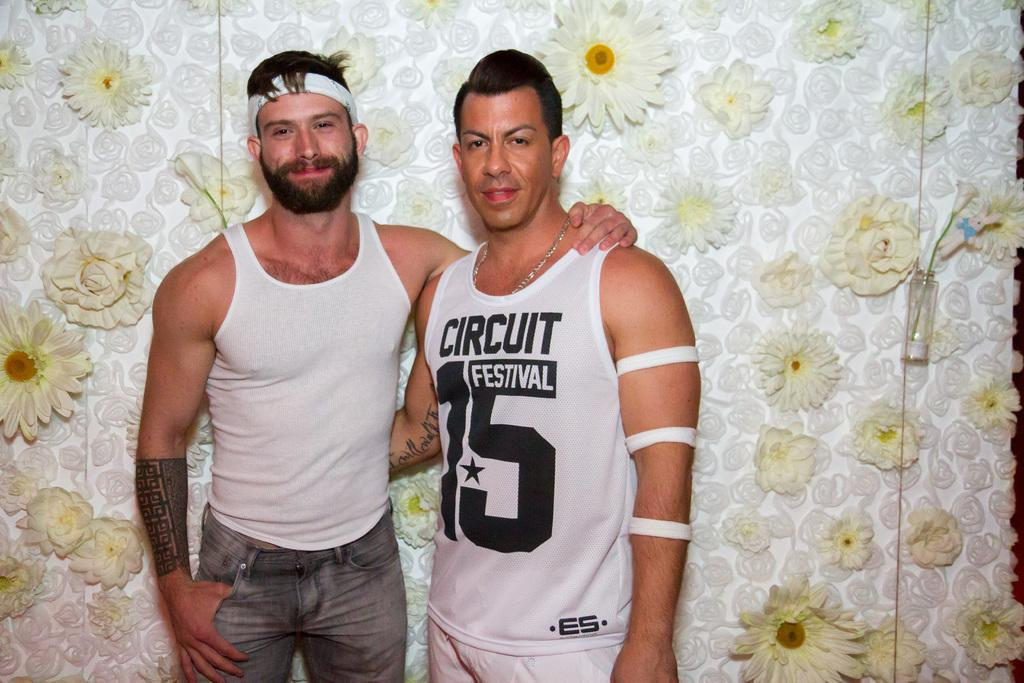<image>
Write a terse but informative summary of the picture. Two guys posing for a picture in front of a flower wall and one has Circuit Festival on his shirt. 